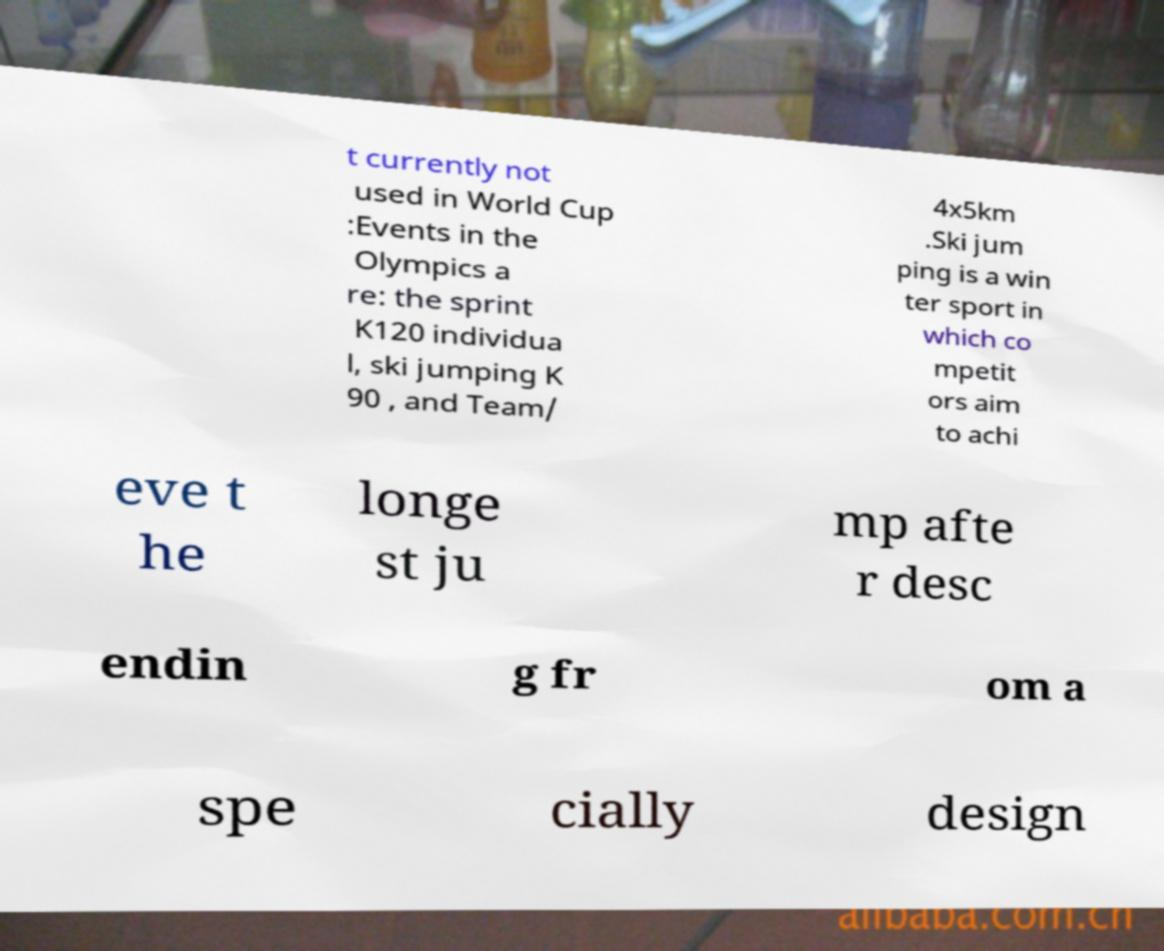I need the written content from this picture converted into text. Can you do that? t currently not used in World Cup :Events in the Olympics a re: the sprint K120 individua l, ski jumping K 90 , and Team/ 4x5km .Ski jum ping is a win ter sport in which co mpetit ors aim to achi eve t he longe st ju mp afte r desc endin g fr om a spe cially design 